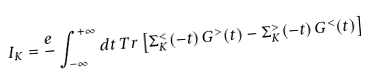Convert formula to latex. <formula><loc_0><loc_0><loc_500><loc_500>I _ { K } = \frac { e } { } \int _ { - \infty } ^ { + \infty } d t \, T r \left [ \Sigma _ { K } ^ { < } ( - t ) \, G ^ { > } ( t ) - \Sigma _ { K } ^ { > } ( - t ) \, G ^ { < } ( t ) \right ]</formula> 